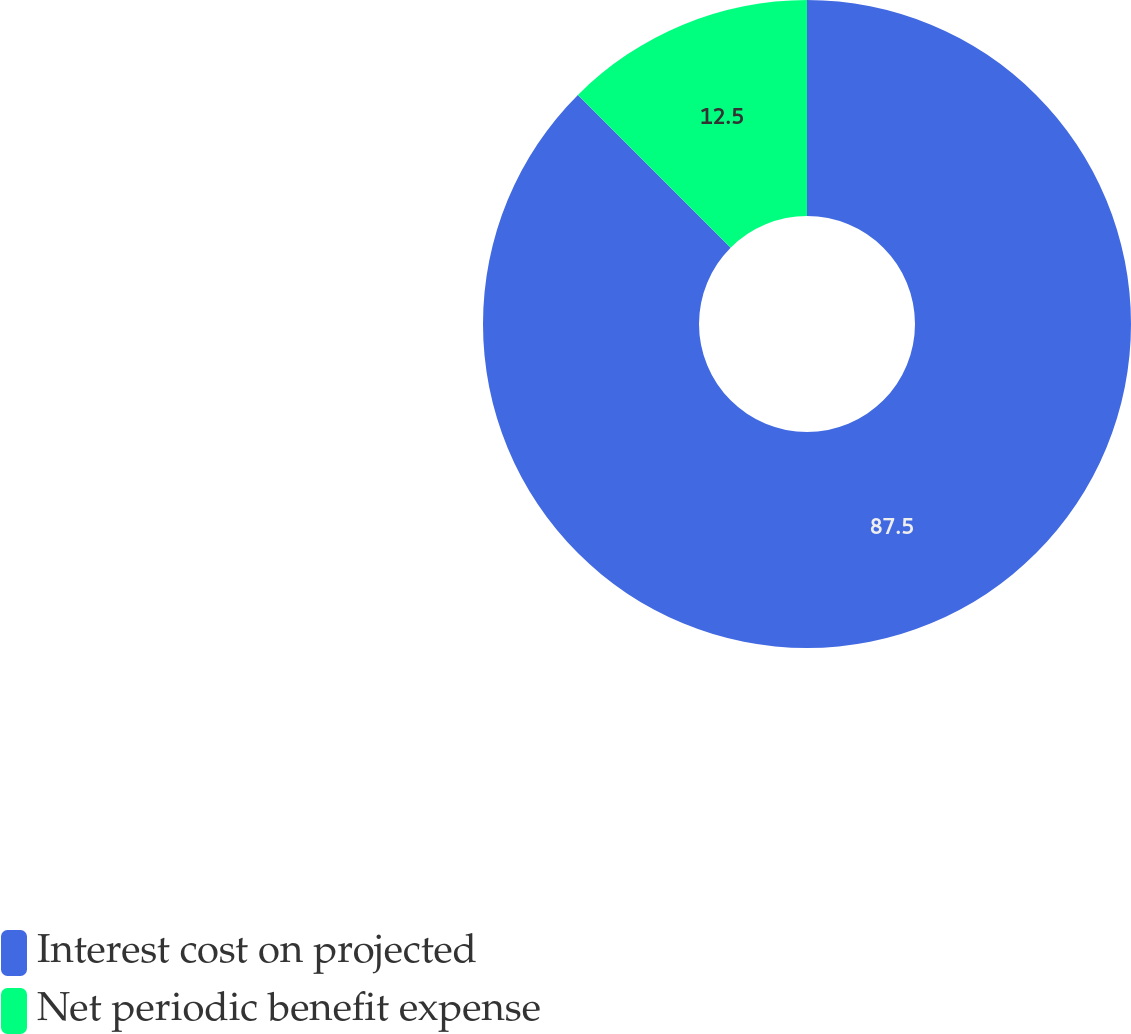Convert chart to OTSL. <chart><loc_0><loc_0><loc_500><loc_500><pie_chart><fcel>Interest cost on projected<fcel>Net periodic benefit expense<nl><fcel>87.5%<fcel>12.5%<nl></chart> 